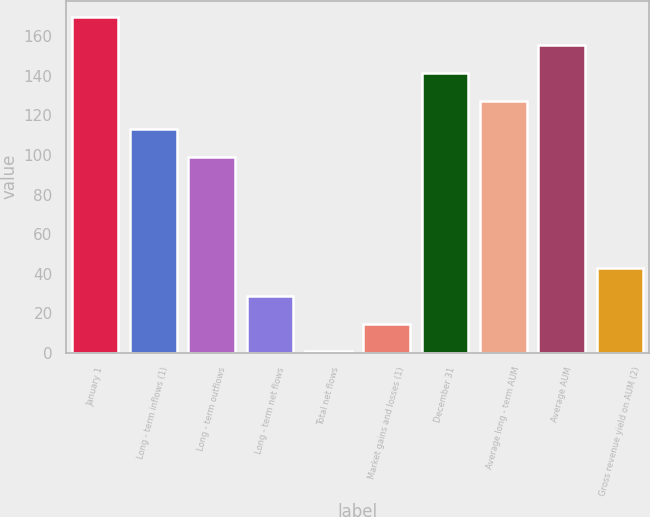Convert chart. <chart><loc_0><loc_0><loc_500><loc_500><bar_chart><fcel>January 1<fcel>Long - term inflows (1)<fcel>Long - term outflows<fcel>Long - term net flows<fcel>Total net flows<fcel>Market gains and losses (1)<fcel>December 31<fcel>Average long - term AUM<fcel>Average AUM<fcel>Gross revenue yield on AUM (2)<nl><fcel>169.54<fcel>113.26<fcel>99.19<fcel>28.84<fcel>0.7<fcel>14.77<fcel>141.4<fcel>127.33<fcel>155.47<fcel>42.91<nl></chart> 